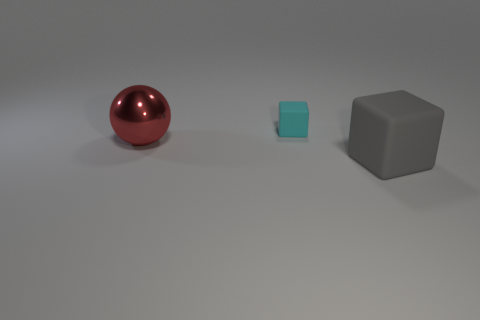Add 1 gray matte cubes. How many objects exist? 4 Subtract all cubes. How many objects are left? 1 Subtract 0 yellow cylinders. How many objects are left? 3 Subtract all cyan blocks. Subtract all yellow cylinders. How many blocks are left? 1 Subtract all large objects. Subtract all yellow metal things. How many objects are left? 1 Add 3 large gray matte blocks. How many large gray matte blocks are left? 4 Add 3 cyan things. How many cyan things exist? 4 